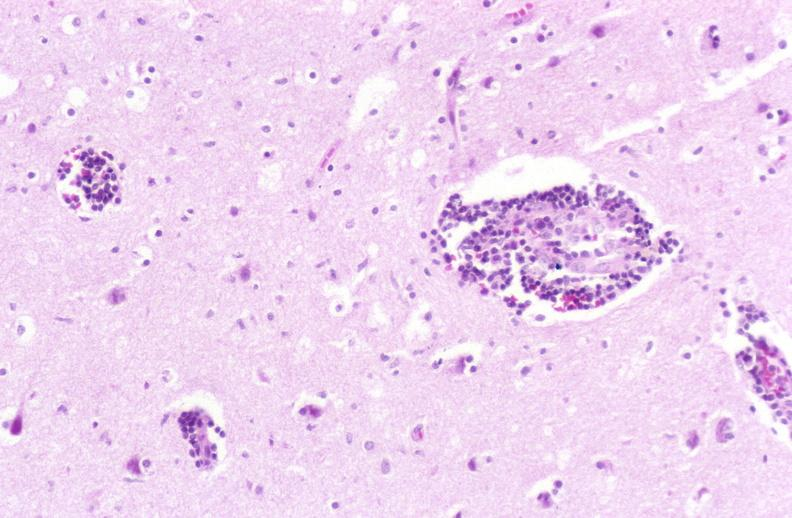does metastatic melanoma show brain, herpes encephalitis, perivascular cuffing?
Answer the question using a single word or phrase. No 